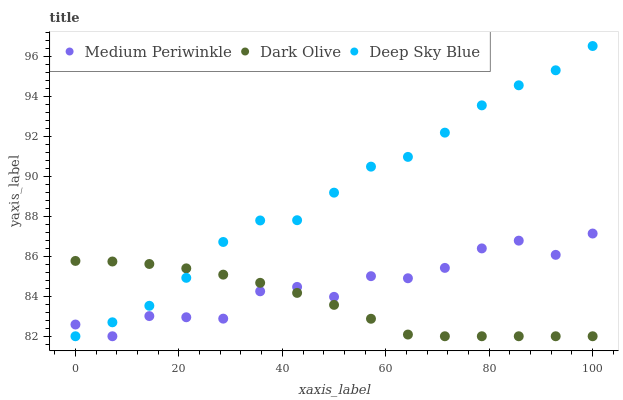Does Dark Olive have the minimum area under the curve?
Answer yes or no. Yes. Does Deep Sky Blue have the maximum area under the curve?
Answer yes or no. Yes. Does Medium Periwinkle have the minimum area under the curve?
Answer yes or no. No. Does Medium Periwinkle have the maximum area under the curve?
Answer yes or no. No. Is Dark Olive the smoothest?
Answer yes or no. Yes. Is Medium Periwinkle the roughest?
Answer yes or no. Yes. Is Deep Sky Blue the smoothest?
Answer yes or no. No. Is Deep Sky Blue the roughest?
Answer yes or no. No. Does Dark Olive have the lowest value?
Answer yes or no. Yes. Does Deep Sky Blue have the highest value?
Answer yes or no. Yes. Does Medium Periwinkle have the highest value?
Answer yes or no. No. Does Medium Periwinkle intersect Deep Sky Blue?
Answer yes or no. Yes. Is Medium Periwinkle less than Deep Sky Blue?
Answer yes or no. No. Is Medium Periwinkle greater than Deep Sky Blue?
Answer yes or no. No. 